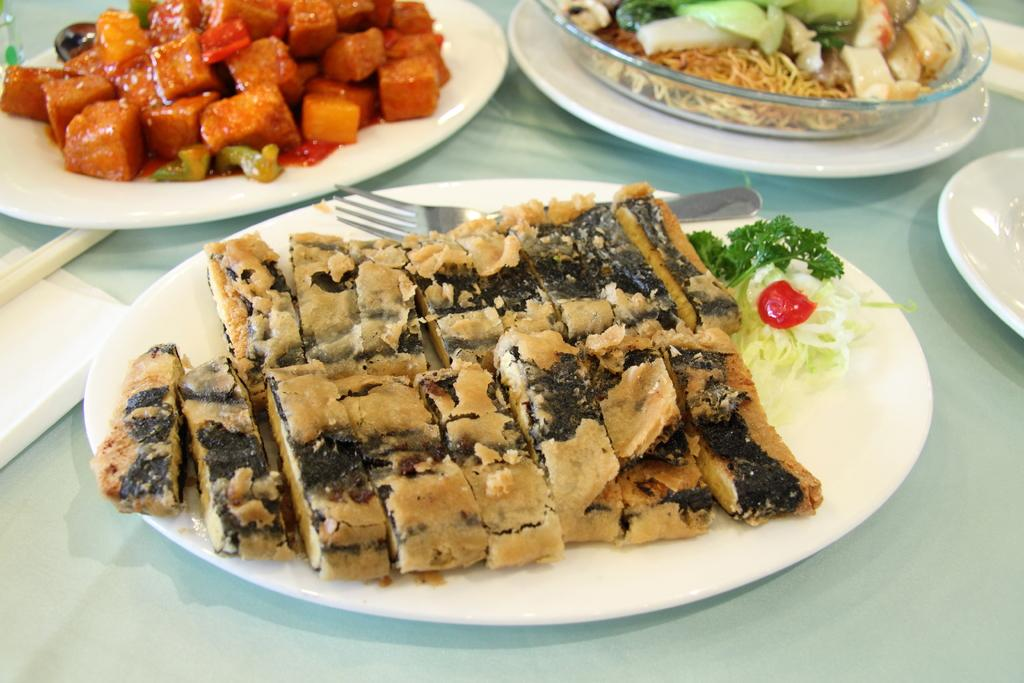What type of objects can be seen in the image? There are food items in the image. What utensil is present with the food items? A fork is present in the image. Where are the food items and fork placed? They are placed on a plate. On what surface is the plate located? The plate is placed on a table. What type of treatment is being administered to the doll in the image? There is no doll present in the image, so no treatment is being administered. 